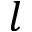Convert formula to latex. <formula><loc_0><loc_0><loc_500><loc_500>l</formula> 